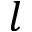Convert formula to latex. <formula><loc_0><loc_0><loc_500><loc_500>l</formula> 